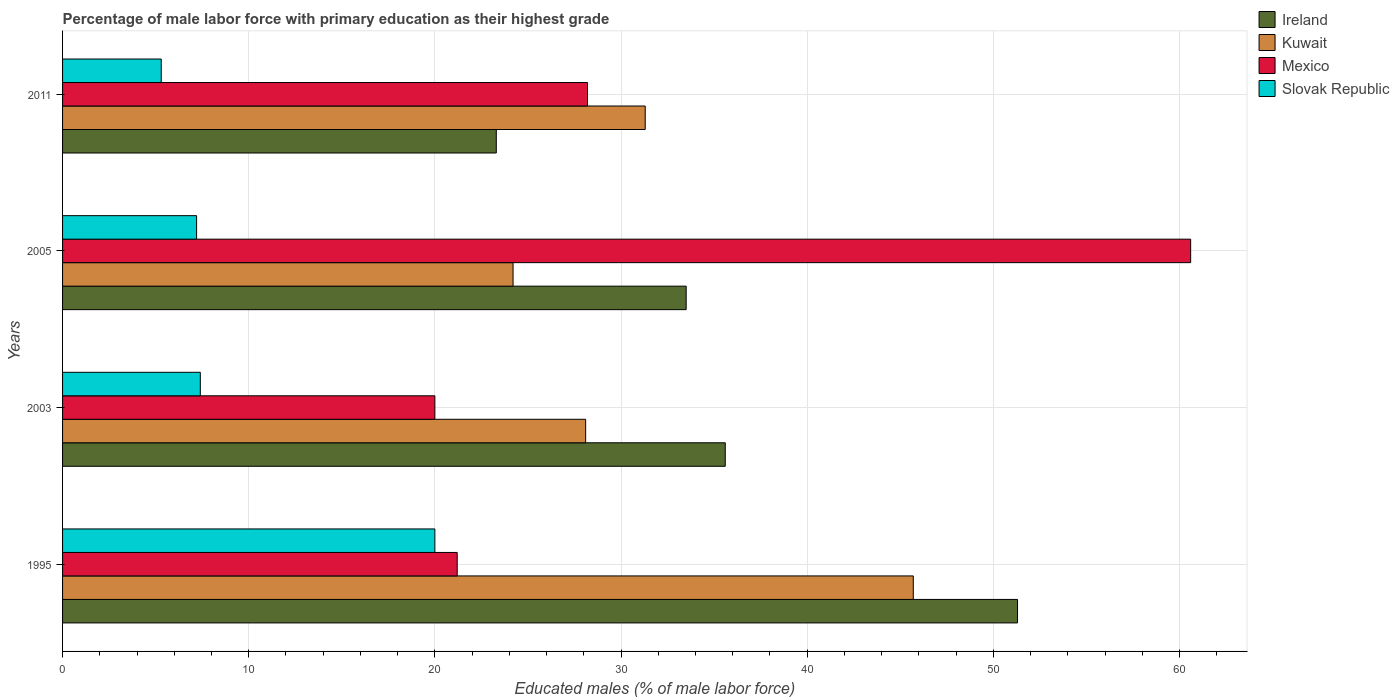How many different coloured bars are there?
Offer a terse response. 4. How many groups of bars are there?
Offer a terse response. 4. Are the number of bars on each tick of the Y-axis equal?
Offer a very short reply. Yes. How many bars are there on the 2nd tick from the bottom?
Provide a short and direct response. 4. What is the label of the 2nd group of bars from the top?
Provide a short and direct response. 2005. In how many cases, is the number of bars for a given year not equal to the number of legend labels?
Give a very brief answer. 0. Across all years, what is the maximum percentage of male labor force with primary education in Kuwait?
Provide a short and direct response. 45.7. Across all years, what is the minimum percentage of male labor force with primary education in Slovak Republic?
Ensure brevity in your answer.  5.3. In which year was the percentage of male labor force with primary education in Ireland maximum?
Provide a short and direct response. 1995. In which year was the percentage of male labor force with primary education in Kuwait minimum?
Provide a short and direct response. 2005. What is the total percentage of male labor force with primary education in Mexico in the graph?
Your response must be concise. 130. What is the difference between the percentage of male labor force with primary education in Ireland in 1995 and that in 2003?
Your answer should be compact. 15.7. What is the difference between the percentage of male labor force with primary education in Slovak Republic in 2011 and the percentage of male labor force with primary education in Mexico in 2003?
Offer a terse response. -14.7. What is the average percentage of male labor force with primary education in Kuwait per year?
Provide a succinct answer. 32.33. In the year 2005, what is the difference between the percentage of male labor force with primary education in Mexico and percentage of male labor force with primary education in Slovak Republic?
Your response must be concise. 53.4. What is the ratio of the percentage of male labor force with primary education in Slovak Republic in 1995 to that in 2005?
Keep it short and to the point. 2.78. What is the difference between the highest and the second highest percentage of male labor force with primary education in Ireland?
Give a very brief answer. 15.7. What is the difference between the highest and the lowest percentage of male labor force with primary education in Kuwait?
Offer a very short reply. 21.5. Is it the case that in every year, the sum of the percentage of male labor force with primary education in Mexico and percentage of male labor force with primary education in Slovak Republic is greater than the sum of percentage of male labor force with primary education in Kuwait and percentage of male labor force with primary education in Ireland?
Provide a short and direct response. Yes. What does the 3rd bar from the top in 2003 represents?
Your response must be concise. Kuwait. What does the 2nd bar from the bottom in 2003 represents?
Provide a short and direct response. Kuwait. Is it the case that in every year, the sum of the percentage of male labor force with primary education in Ireland and percentage of male labor force with primary education in Mexico is greater than the percentage of male labor force with primary education in Slovak Republic?
Keep it short and to the point. Yes. How many bars are there?
Offer a terse response. 16. How many years are there in the graph?
Your response must be concise. 4. Are the values on the major ticks of X-axis written in scientific E-notation?
Make the answer very short. No. Does the graph contain any zero values?
Offer a terse response. No. How many legend labels are there?
Keep it short and to the point. 4. How are the legend labels stacked?
Make the answer very short. Vertical. What is the title of the graph?
Provide a succinct answer. Percentage of male labor force with primary education as their highest grade. Does "Myanmar" appear as one of the legend labels in the graph?
Keep it short and to the point. No. What is the label or title of the X-axis?
Your response must be concise. Educated males (% of male labor force). What is the Educated males (% of male labor force) of Ireland in 1995?
Offer a terse response. 51.3. What is the Educated males (% of male labor force) of Kuwait in 1995?
Keep it short and to the point. 45.7. What is the Educated males (% of male labor force) of Mexico in 1995?
Offer a very short reply. 21.2. What is the Educated males (% of male labor force) of Slovak Republic in 1995?
Give a very brief answer. 20. What is the Educated males (% of male labor force) in Ireland in 2003?
Ensure brevity in your answer.  35.6. What is the Educated males (% of male labor force) of Kuwait in 2003?
Ensure brevity in your answer.  28.1. What is the Educated males (% of male labor force) of Mexico in 2003?
Provide a short and direct response. 20. What is the Educated males (% of male labor force) in Slovak Republic in 2003?
Give a very brief answer. 7.4. What is the Educated males (% of male labor force) of Ireland in 2005?
Give a very brief answer. 33.5. What is the Educated males (% of male labor force) in Kuwait in 2005?
Your answer should be very brief. 24.2. What is the Educated males (% of male labor force) of Mexico in 2005?
Make the answer very short. 60.6. What is the Educated males (% of male labor force) of Slovak Republic in 2005?
Your answer should be compact. 7.2. What is the Educated males (% of male labor force) of Ireland in 2011?
Your answer should be very brief. 23.3. What is the Educated males (% of male labor force) in Kuwait in 2011?
Provide a short and direct response. 31.3. What is the Educated males (% of male labor force) of Mexico in 2011?
Make the answer very short. 28.2. What is the Educated males (% of male labor force) of Slovak Republic in 2011?
Provide a short and direct response. 5.3. Across all years, what is the maximum Educated males (% of male labor force) in Ireland?
Your answer should be compact. 51.3. Across all years, what is the maximum Educated males (% of male labor force) of Kuwait?
Offer a very short reply. 45.7. Across all years, what is the maximum Educated males (% of male labor force) of Mexico?
Make the answer very short. 60.6. Across all years, what is the maximum Educated males (% of male labor force) of Slovak Republic?
Provide a succinct answer. 20. Across all years, what is the minimum Educated males (% of male labor force) of Ireland?
Ensure brevity in your answer.  23.3. Across all years, what is the minimum Educated males (% of male labor force) of Kuwait?
Make the answer very short. 24.2. Across all years, what is the minimum Educated males (% of male labor force) in Slovak Republic?
Make the answer very short. 5.3. What is the total Educated males (% of male labor force) in Ireland in the graph?
Your response must be concise. 143.7. What is the total Educated males (% of male labor force) in Kuwait in the graph?
Your answer should be very brief. 129.3. What is the total Educated males (% of male labor force) in Mexico in the graph?
Your answer should be very brief. 130. What is the total Educated males (% of male labor force) of Slovak Republic in the graph?
Offer a very short reply. 39.9. What is the difference between the Educated males (% of male labor force) of Ireland in 1995 and that in 2005?
Ensure brevity in your answer.  17.8. What is the difference between the Educated males (% of male labor force) of Kuwait in 1995 and that in 2005?
Your response must be concise. 21.5. What is the difference between the Educated males (% of male labor force) in Mexico in 1995 and that in 2005?
Provide a succinct answer. -39.4. What is the difference between the Educated males (% of male labor force) in Slovak Republic in 1995 and that in 2005?
Offer a very short reply. 12.8. What is the difference between the Educated males (% of male labor force) of Ireland in 1995 and that in 2011?
Your answer should be very brief. 28. What is the difference between the Educated males (% of male labor force) in Kuwait in 1995 and that in 2011?
Make the answer very short. 14.4. What is the difference between the Educated males (% of male labor force) in Slovak Republic in 1995 and that in 2011?
Give a very brief answer. 14.7. What is the difference between the Educated males (% of male labor force) of Ireland in 2003 and that in 2005?
Make the answer very short. 2.1. What is the difference between the Educated males (% of male labor force) of Mexico in 2003 and that in 2005?
Provide a short and direct response. -40.6. What is the difference between the Educated males (% of male labor force) of Slovak Republic in 2003 and that in 2005?
Your answer should be compact. 0.2. What is the difference between the Educated males (% of male labor force) of Kuwait in 2003 and that in 2011?
Offer a very short reply. -3.2. What is the difference between the Educated males (% of male labor force) in Mexico in 2003 and that in 2011?
Offer a terse response. -8.2. What is the difference between the Educated males (% of male labor force) of Slovak Republic in 2003 and that in 2011?
Your answer should be very brief. 2.1. What is the difference between the Educated males (% of male labor force) of Ireland in 2005 and that in 2011?
Offer a terse response. 10.2. What is the difference between the Educated males (% of male labor force) of Mexico in 2005 and that in 2011?
Provide a short and direct response. 32.4. What is the difference between the Educated males (% of male labor force) of Slovak Republic in 2005 and that in 2011?
Ensure brevity in your answer.  1.9. What is the difference between the Educated males (% of male labor force) of Ireland in 1995 and the Educated males (% of male labor force) of Kuwait in 2003?
Provide a short and direct response. 23.2. What is the difference between the Educated males (% of male labor force) of Ireland in 1995 and the Educated males (% of male labor force) of Mexico in 2003?
Your answer should be compact. 31.3. What is the difference between the Educated males (% of male labor force) of Ireland in 1995 and the Educated males (% of male labor force) of Slovak Republic in 2003?
Make the answer very short. 43.9. What is the difference between the Educated males (% of male labor force) of Kuwait in 1995 and the Educated males (% of male labor force) of Mexico in 2003?
Offer a very short reply. 25.7. What is the difference between the Educated males (% of male labor force) in Kuwait in 1995 and the Educated males (% of male labor force) in Slovak Republic in 2003?
Give a very brief answer. 38.3. What is the difference between the Educated males (% of male labor force) in Mexico in 1995 and the Educated males (% of male labor force) in Slovak Republic in 2003?
Your response must be concise. 13.8. What is the difference between the Educated males (% of male labor force) in Ireland in 1995 and the Educated males (% of male labor force) in Kuwait in 2005?
Give a very brief answer. 27.1. What is the difference between the Educated males (% of male labor force) of Ireland in 1995 and the Educated males (% of male labor force) of Mexico in 2005?
Your response must be concise. -9.3. What is the difference between the Educated males (% of male labor force) of Ireland in 1995 and the Educated males (% of male labor force) of Slovak Republic in 2005?
Ensure brevity in your answer.  44.1. What is the difference between the Educated males (% of male labor force) in Kuwait in 1995 and the Educated males (% of male labor force) in Mexico in 2005?
Provide a short and direct response. -14.9. What is the difference between the Educated males (% of male labor force) of Kuwait in 1995 and the Educated males (% of male labor force) of Slovak Republic in 2005?
Give a very brief answer. 38.5. What is the difference between the Educated males (% of male labor force) of Ireland in 1995 and the Educated males (% of male labor force) of Mexico in 2011?
Give a very brief answer. 23.1. What is the difference between the Educated males (% of male labor force) of Kuwait in 1995 and the Educated males (% of male labor force) of Mexico in 2011?
Keep it short and to the point. 17.5. What is the difference between the Educated males (% of male labor force) in Kuwait in 1995 and the Educated males (% of male labor force) in Slovak Republic in 2011?
Make the answer very short. 40.4. What is the difference between the Educated males (% of male labor force) of Ireland in 2003 and the Educated males (% of male labor force) of Kuwait in 2005?
Your answer should be compact. 11.4. What is the difference between the Educated males (% of male labor force) in Ireland in 2003 and the Educated males (% of male labor force) in Mexico in 2005?
Your answer should be compact. -25. What is the difference between the Educated males (% of male labor force) of Ireland in 2003 and the Educated males (% of male labor force) of Slovak Republic in 2005?
Make the answer very short. 28.4. What is the difference between the Educated males (% of male labor force) in Kuwait in 2003 and the Educated males (% of male labor force) in Mexico in 2005?
Make the answer very short. -32.5. What is the difference between the Educated males (% of male labor force) in Kuwait in 2003 and the Educated males (% of male labor force) in Slovak Republic in 2005?
Keep it short and to the point. 20.9. What is the difference between the Educated males (% of male labor force) in Ireland in 2003 and the Educated males (% of male labor force) in Slovak Republic in 2011?
Keep it short and to the point. 30.3. What is the difference between the Educated males (% of male labor force) in Kuwait in 2003 and the Educated males (% of male labor force) in Slovak Republic in 2011?
Make the answer very short. 22.8. What is the difference between the Educated males (% of male labor force) of Mexico in 2003 and the Educated males (% of male labor force) of Slovak Republic in 2011?
Keep it short and to the point. 14.7. What is the difference between the Educated males (% of male labor force) in Ireland in 2005 and the Educated males (% of male labor force) in Kuwait in 2011?
Keep it short and to the point. 2.2. What is the difference between the Educated males (% of male labor force) of Ireland in 2005 and the Educated males (% of male labor force) of Slovak Republic in 2011?
Ensure brevity in your answer.  28.2. What is the difference between the Educated males (% of male labor force) of Kuwait in 2005 and the Educated males (% of male labor force) of Mexico in 2011?
Offer a very short reply. -4. What is the difference between the Educated males (% of male labor force) of Mexico in 2005 and the Educated males (% of male labor force) of Slovak Republic in 2011?
Your answer should be compact. 55.3. What is the average Educated males (% of male labor force) of Ireland per year?
Your response must be concise. 35.92. What is the average Educated males (% of male labor force) in Kuwait per year?
Ensure brevity in your answer.  32.33. What is the average Educated males (% of male labor force) of Mexico per year?
Provide a short and direct response. 32.5. What is the average Educated males (% of male labor force) of Slovak Republic per year?
Your answer should be compact. 9.97. In the year 1995, what is the difference between the Educated males (% of male labor force) of Ireland and Educated males (% of male labor force) of Mexico?
Provide a succinct answer. 30.1. In the year 1995, what is the difference between the Educated males (% of male labor force) of Ireland and Educated males (% of male labor force) of Slovak Republic?
Offer a very short reply. 31.3. In the year 1995, what is the difference between the Educated males (% of male labor force) of Kuwait and Educated males (% of male labor force) of Slovak Republic?
Offer a terse response. 25.7. In the year 2003, what is the difference between the Educated males (% of male labor force) in Ireland and Educated males (% of male labor force) in Mexico?
Make the answer very short. 15.6. In the year 2003, what is the difference between the Educated males (% of male labor force) of Ireland and Educated males (% of male labor force) of Slovak Republic?
Provide a short and direct response. 28.2. In the year 2003, what is the difference between the Educated males (% of male labor force) of Kuwait and Educated males (% of male labor force) of Slovak Republic?
Offer a very short reply. 20.7. In the year 2003, what is the difference between the Educated males (% of male labor force) in Mexico and Educated males (% of male labor force) in Slovak Republic?
Keep it short and to the point. 12.6. In the year 2005, what is the difference between the Educated males (% of male labor force) of Ireland and Educated males (% of male labor force) of Mexico?
Your answer should be compact. -27.1. In the year 2005, what is the difference between the Educated males (% of male labor force) of Ireland and Educated males (% of male labor force) of Slovak Republic?
Provide a short and direct response. 26.3. In the year 2005, what is the difference between the Educated males (% of male labor force) of Kuwait and Educated males (% of male labor force) of Mexico?
Your response must be concise. -36.4. In the year 2005, what is the difference between the Educated males (% of male labor force) in Mexico and Educated males (% of male labor force) in Slovak Republic?
Provide a short and direct response. 53.4. In the year 2011, what is the difference between the Educated males (% of male labor force) in Ireland and Educated males (% of male labor force) in Kuwait?
Your answer should be compact. -8. In the year 2011, what is the difference between the Educated males (% of male labor force) in Kuwait and Educated males (% of male labor force) in Mexico?
Offer a very short reply. 3.1. In the year 2011, what is the difference between the Educated males (% of male labor force) of Kuwait and Educated males (% of male labor force) of Slovak Republic?
Keep it short and to the point. 26. In the year 2011, what is the difference between the Educated males (% of male labor force) in Mexico and Educated males (% of male labor force) in Slovak Republic?
Make the answer very short. 22.9. What is the ratio of the Educated males (% of male labor force) in Ireland in 1995 to that in 2003?
Give a very brief answer. 1.44. What is the ratio of the Educated males (% of male labor force) in Kuwait in 1995 to that in 2003?
Provide a succinct answer. 1.63. What is the ratio of the Educated males (% of male labor force) in Mexico in 1995 to that in 2003?
Your response must be concise. 1.06. What is the ratio of the Educated males (% of male labor force) of Slovak Republic in 1995 to that in 2003?
Your answer should be very brief. 2.7. What is the ratio of the Educated males (% of male labor force) in Ireland in 1995 to that in 2005?
Keep it short and to the point. 1.53. What is the ratio of the Educated males (% of male labor force) in Kuwait in 1995 to that in 2005?
Provide a succinct answer. 1.89. What is the ratio of the Educated males (% of male labor force) of Mexico in 1995 to that in 2005?
Your response must be concise. 0.35. What is the ratio of the Educated males (% of male labor force) of Slovak Republic in 1995 to that in 2005?
Ensure brevity in your answer.  2.78. What is the ratio of the Educated males (% of male labor force) of Ireland in 1995 to that in 2011?
Your answer should be compact. 2.2. What is the ratio of the Educated males (% of male labor force) in Kuwait in 1995 to that in 2011?
Provide a succinct answer. 1.46. What is the ratio of the Educated males (% of male labor force) in Mexico in 1995 to that in 2011?
Provide a succinct answer. 0.75. What is the ratio of the Educated males (% of male labor force) of Slovak Republic in 1995 to that in 2011?
Ensure brevity in your answer.  3.77. What is the ratio of the Educated males (% of male labor force) in Ireland in 2003 to that in 2005?
Give a very brief answer. 1.06. What is the ratio of the Educated males (% of male labor force) of Kuwait in 2003 to that in 2005?
Give a very brief answer. 1.16. What is the ratio of the Educated males (% of male labor force) in Mexico in 2003 to that in 2005?
Offer a terse response. 0.33. What is the ratio of the Educated males (% of male labor force) of Slovak Republic in 2003 to that in 2005?
Give a very brief answer. 1.03. What is the ratio of the Educated males (% of male labor force) in Ireland in 2003 to that in 2011?
Provide a short and direct response. 1.53. What is the ratio of the Educated males (% of male labor force) in Kuwait in 2003 to that in 2011?
Keep it short and to the point. 0.9. What is the ratio of the Educated males (% of male labor force) in Mexico in 2003 to that in 2011?
Give a very brief answer. 0.71. What is the ratio of the Educated males (% of male labor force) of Slovak Republic in 2003 to that in 2011?
Ensure brevity in your answer.  1.4. What is the ratio of the Educated males (% of male labor force) in Ireland in 2005 to that in 2011?
Your answer should be compact. 1.44. What is the ratio of the Educated males (% of male labor force) in Kuwait in 2005 to that in 2011?
Your response must be concise. 0.77. What is the ratio of the Educated males (% of male labor force) in Mexico in 2005 to that in 2011?
Provide a succinct answer. 2.15. What is the ratio of the Educated males (% of male labor force) of Slovak Republic in 2005 to that in 2011?
Provide a short and direct response. 1.36. What is the difference between the highest and the second highest Educated males (% of male labor force) in Kuwait?
Make the answer very short. 14.4. What is the difference between the highest and the second highest Educated males (% of male labor force) of Mexico?
Give a very brief answer. 32.4. What is the difference between the highest and the second highest Educated males (% of male labor force) in Slovak Republic?
Make the answer very short. 12.6. What is the difference between the highest and the lowest Educated males (% of male labor force) of Mexico?
Ensure brevity in your answer.  40.6. What is the difference between the highest and the lowest Educated males (% of male labor force) in Slovak Republic?
Provide a short and direct response. 14.7. 